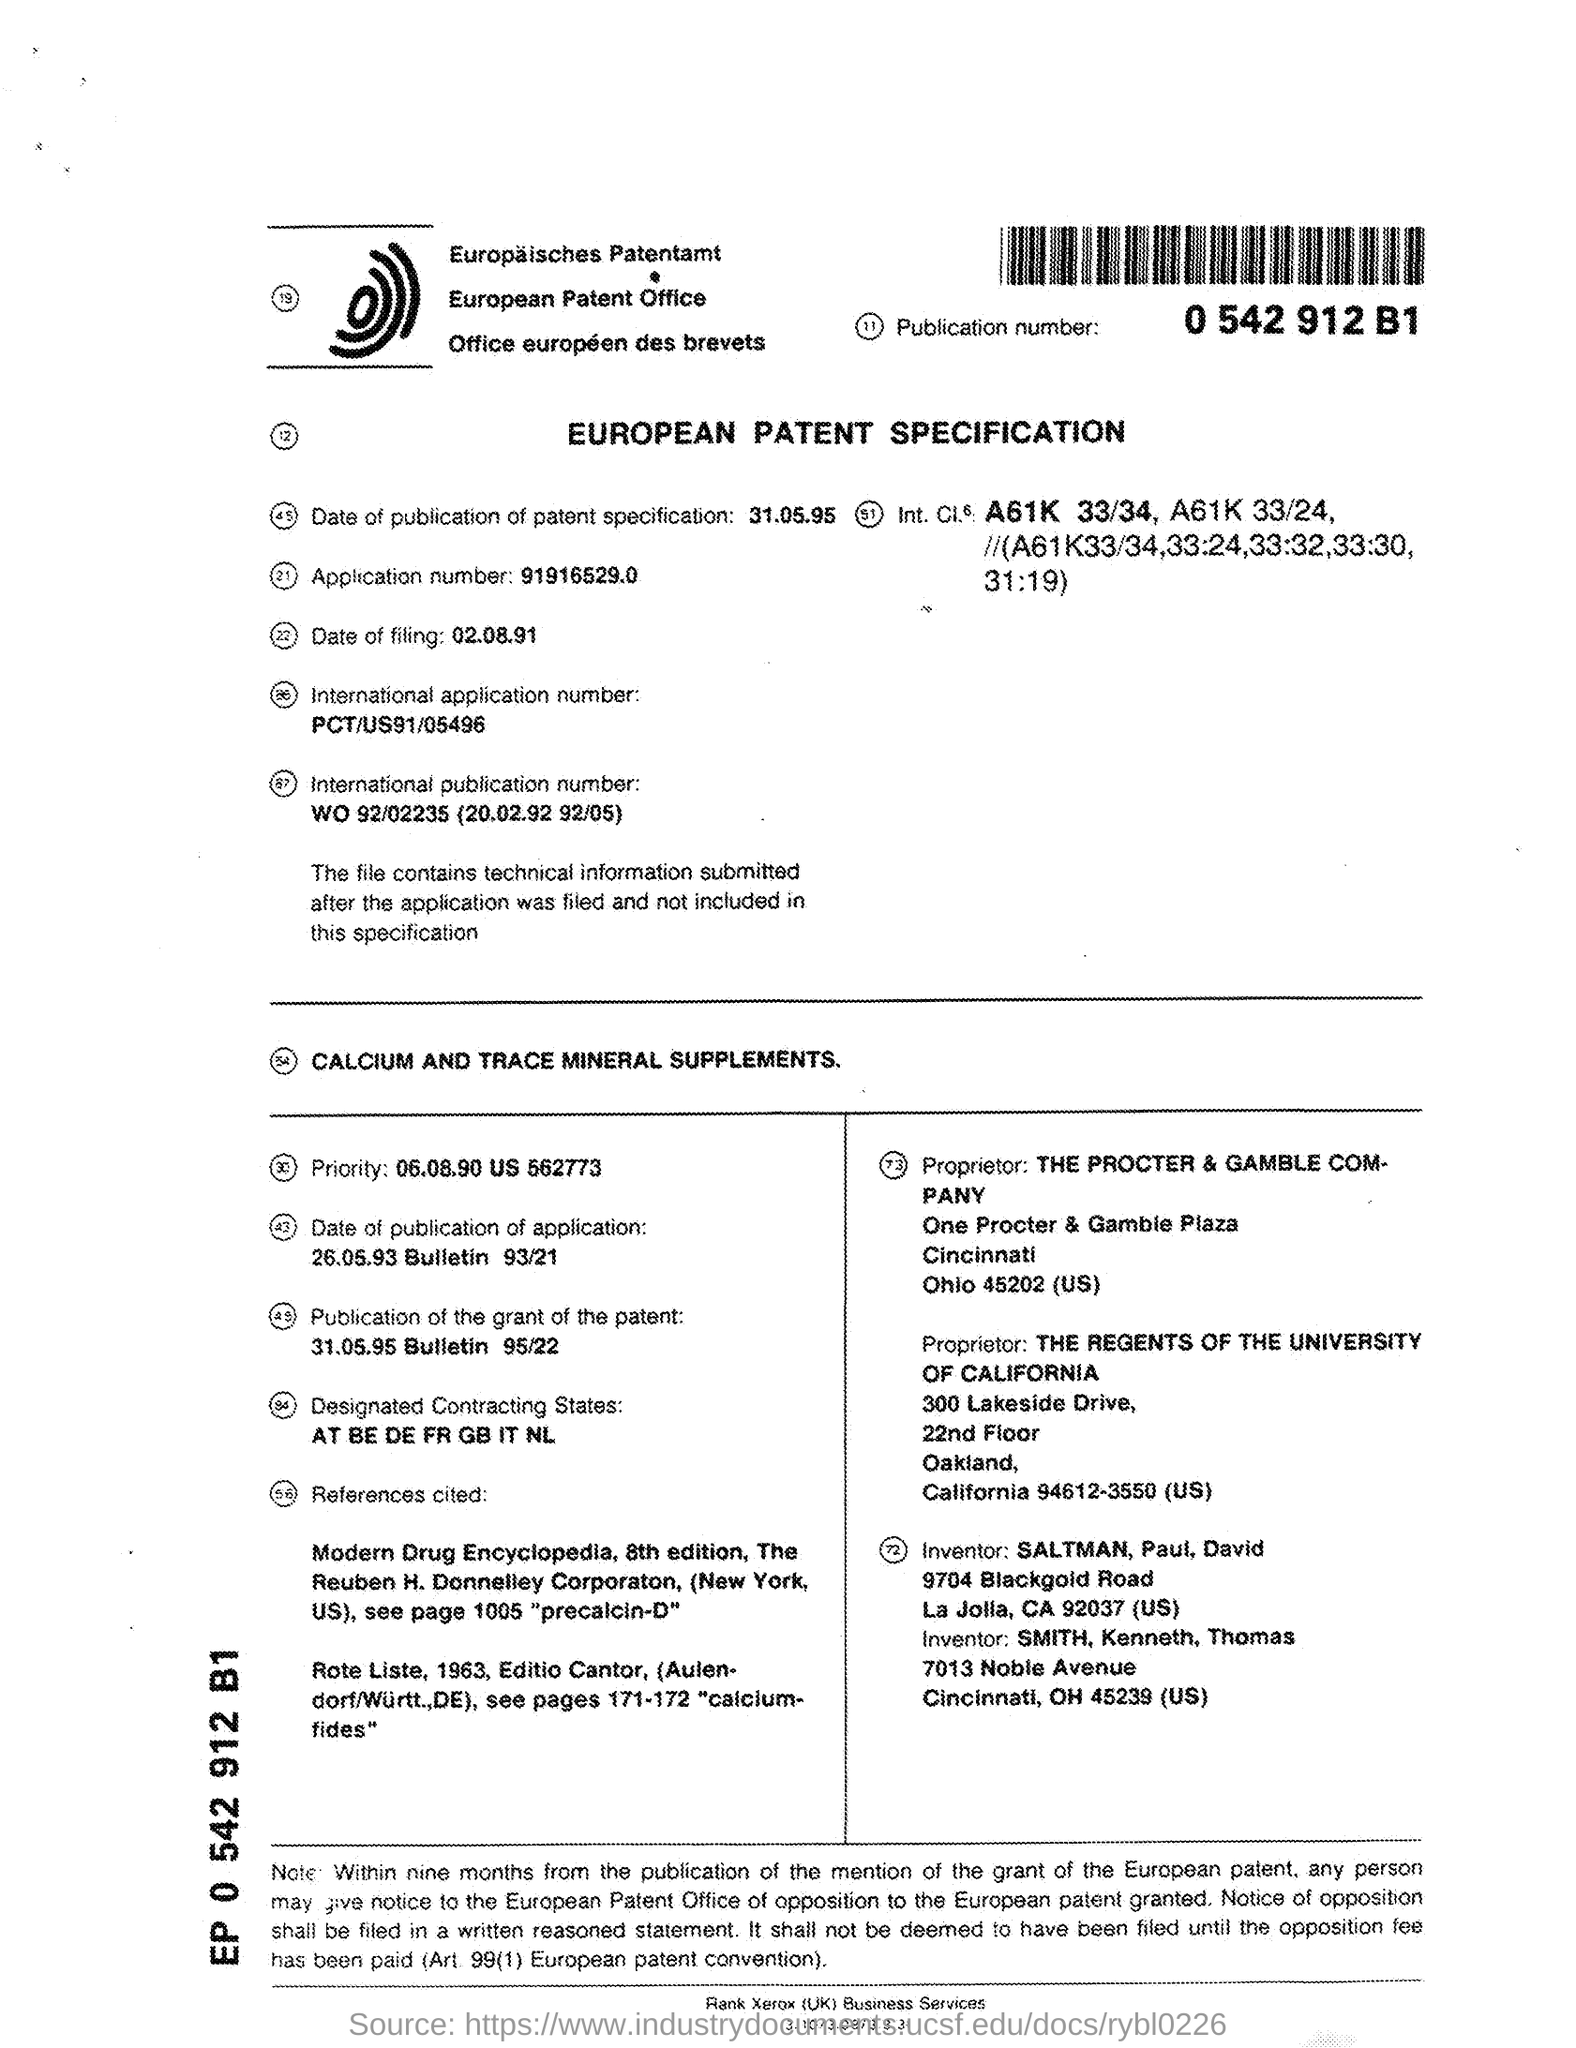Point out several critical features in this image. The publication of the grant of the patent took place on May 31, 1995, as stated in the Bulletin 95/22. On what date was the filing made? The title of the document is the European Patent Specification. The inventors are Saltman, Paul, and David. The International Application Number is PCT/US91/05496. 